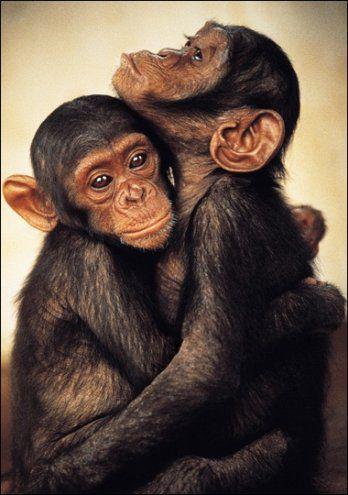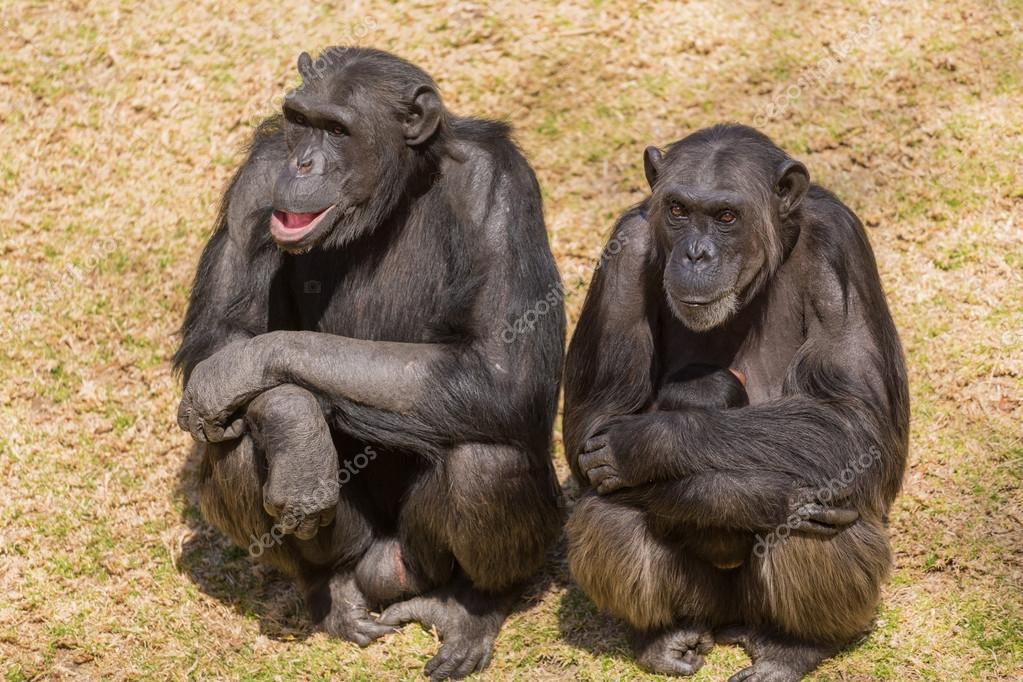The first image is the image on the left, the second image is the image on the right. Evaluate the accuracy of this statement regarding the images: "The apes are hugging each other in both pictures.". Is it true? Answer yes or no. No. The first image is the image on the left, the second image is the image on the right. Analyze the images presented: Is the assertion "chimps are hugging each other in both image pairs" valid? Answer yes or no. No. 